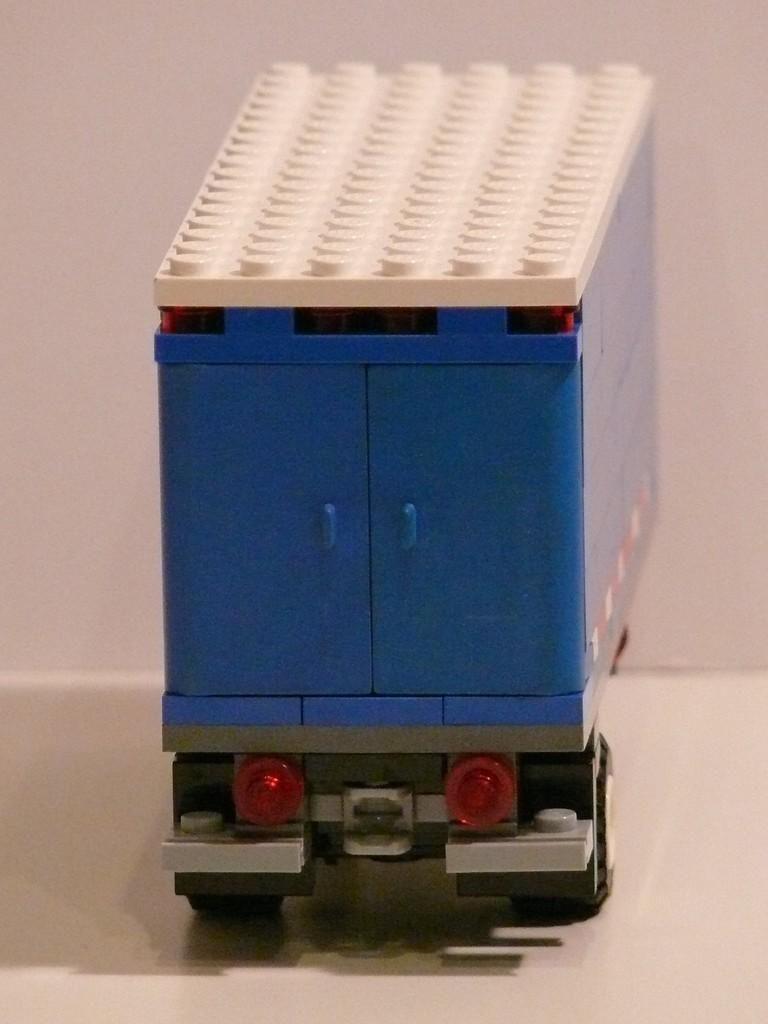What is the main subject of the picture? The main subject of the picture is a truck toy. What color is the surface on which the truck toy is placed? The truck toy is on a white color surface. What color is the truck toy? The truck toy is blue in color. What type of treatment is being administered to the truck toy in the image? There is no treatment being administered to the truck toy in the image; it is simply a toy sitting on a white surface. Can you see a needle in the image? No, there is no needle present in the image. 